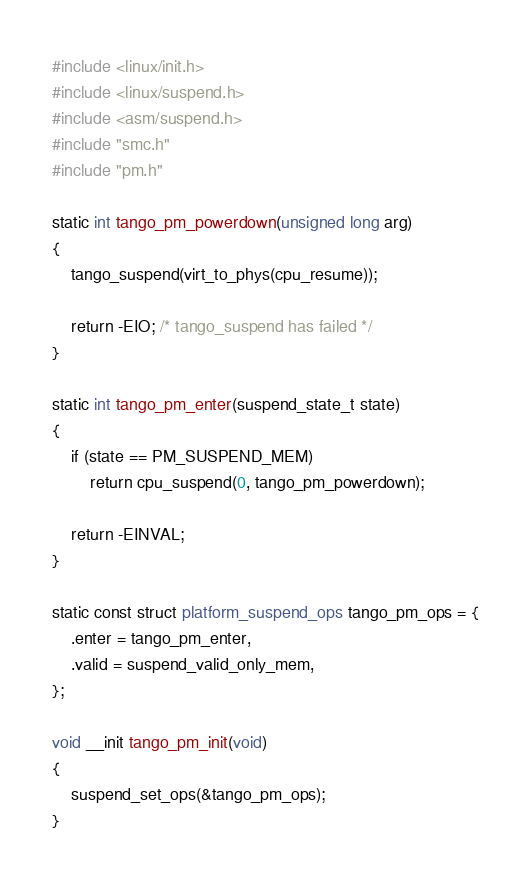<code> <loc_0><loc_0><loc_500><loc_500><_C_>#include <linux/init.h>
#include <linux/suspend.h>
#include <asm/suspend.h>
#include "smc.h"
#include "pm.h"

static int tango_pm_powerdown(unsigned long arg)
{
	tango_suspend(virt_to_phys(cpu_resume));

	return -EIO; /* tango_suspend has failed */
}

static int tango_pm_enter(suspend_state_t state)
{
	if (state == PM_SUSPEND_MEM)
		return cpu_suspend(0, tango_pm_powerdown);

	return -EINVAL;
}

static const struct platform_suspend_ops tango_pm_ops = {
	.enter = tango_pm_enter,
	.valid = suspend_valid_only_mem,
};

void __init tango_pm_init(void)
{
	suspend_set_ops(&tango_pm_ops);
}
</code> 